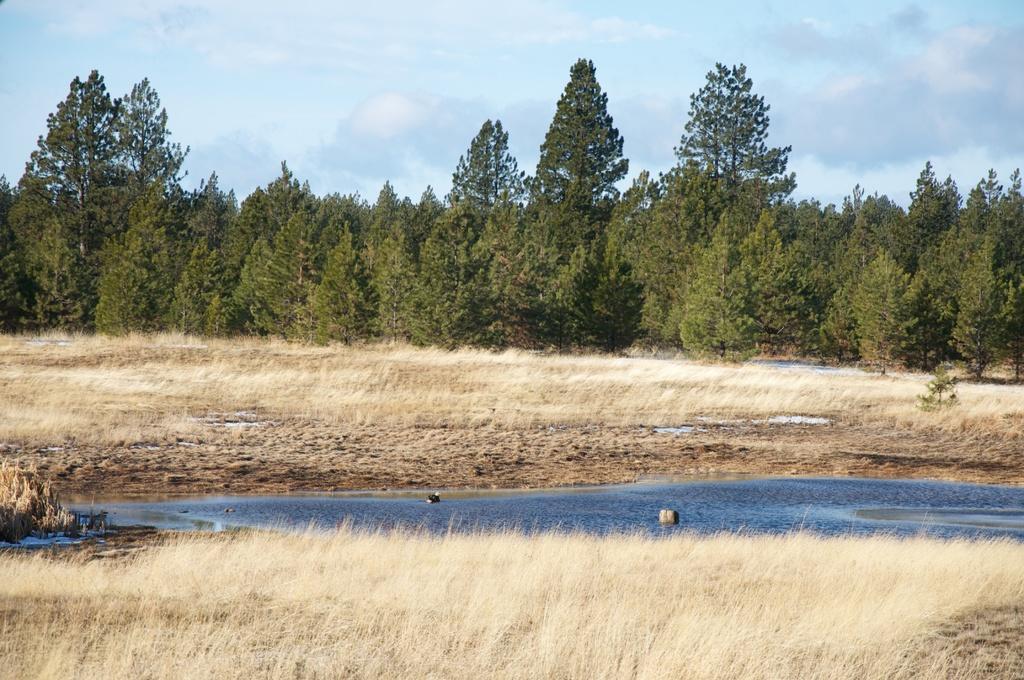Describe this image in one or two sentences. In this image we can see some dried plants, a water body, a group of trees and the sky which looks cloudy. 